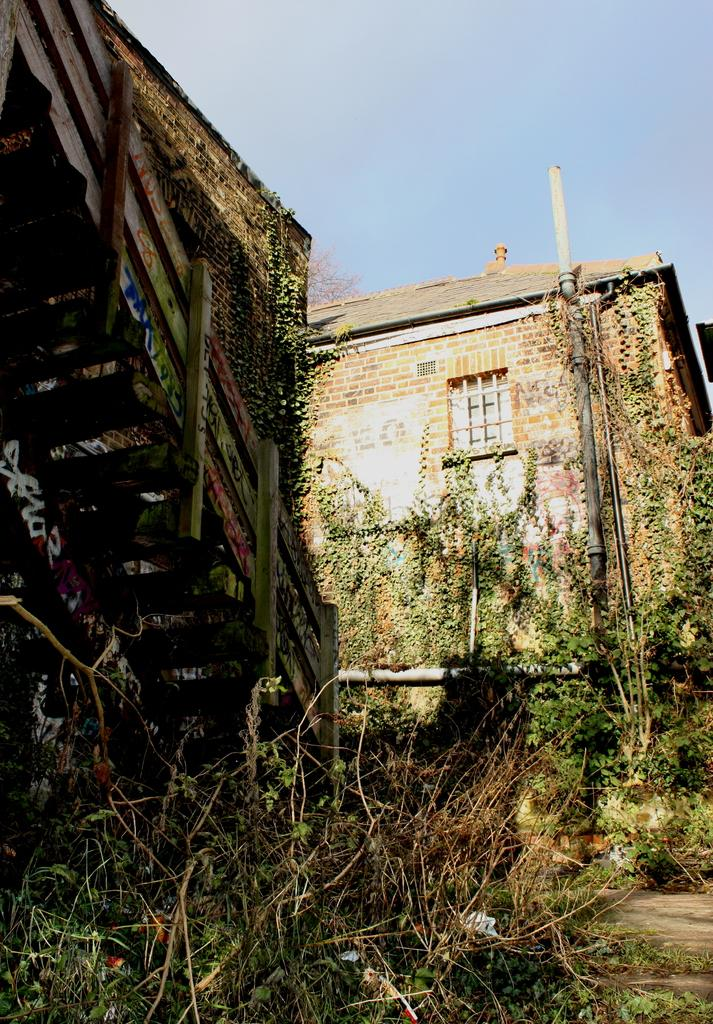What type of structure is visible in the image? There is a house in the image. What feature of the house is mentioned in the facts? The house has windows. What architectural element can be seen in the image? There is a staircase in the image. What type of vegetation is present at the bottom of the image? Plants are present at the bottom of the image. What is visible at the top of the image? The sky is visible at the top of the image. How much does the basketball weigh in the image? There is no basketball present in the image, so its weight cannot be determined. 